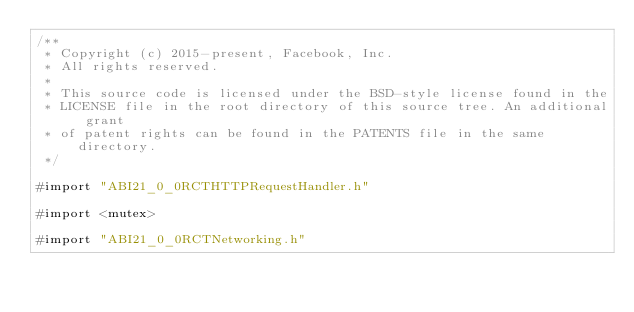<code> <loc_0><loc_0><loc_500><loc_500><_ObjectiveC_>/**
 * Copyright (c) 2015-present, Facebook, Inc.
 * All rights reserved.
 *
 * This source code is licensed under the BSD-style license found in the
 * LICENSE file in the root directory of this source tree. An additional grant
 * of patent rights can be found in the PATENTS file in the same directory.
 */

#import "ABI21_0_0RCTHTTPRequestHandler.h"

#import <mutex>

#import "ABI21_0_0RCTNetworking.h"
</code> 